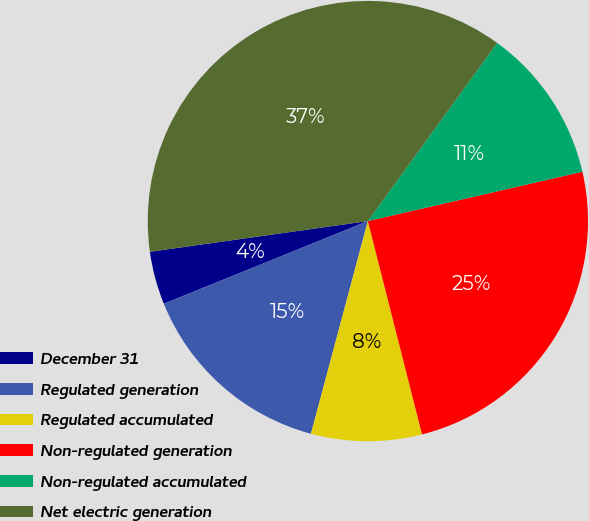<chart> <loc_0><loc_0><loc_500><loc_500><pie_chart><fcel>December 31<fcel>Regulated generation<fcel>Regulated accumulated<fcel>Non-regulated generation<fcel>Non-regulated accumulated<fcel>Net electric generation<nl><fcel>3.9%<fcel>14.71%<fcel>8.12%<fcel>24.64%<fcel>11.41%<fcel>37.22%<nl></chart> 